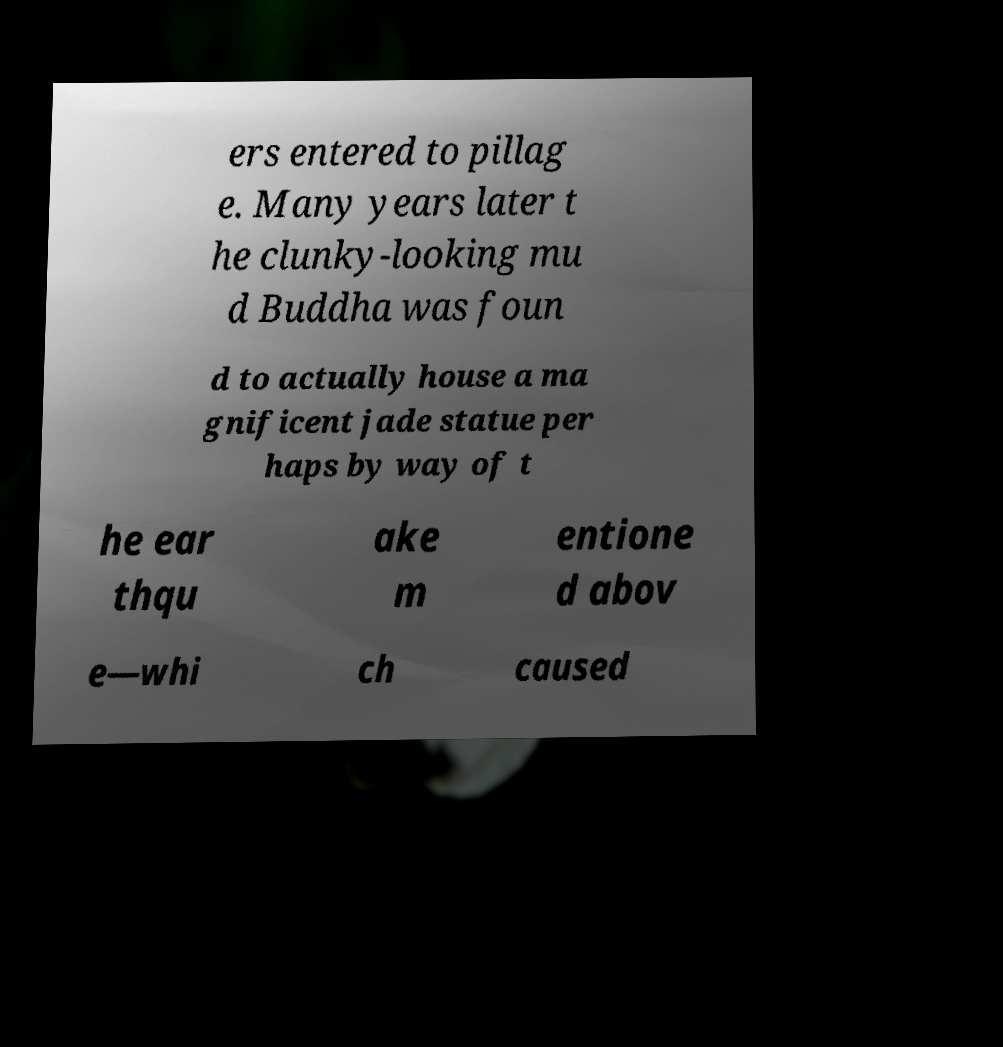Can you accurately transcribe the text from the provided image for me? ers entered to pillag e. Many years later t he clunky-looking mu d Buddha was foun d to actually house a ma gnificent jade statue per haps by way of t he ear thqu ake m entione d abov e—whi ch caused 